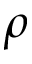Convert formula to latex. <formula><loc_0><loc_0><loc_500><loc_500>\rho</formula> 